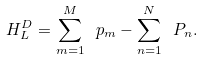<formula> <loc_0><loc_0><loc_500><loc_500>H ^ { D } _ { L } = \sum _ { m = 1 } ^ { M } \ p _ { m } - \sum _ { n = 1 } ^ { N } \ P _ { n } .</formula> 